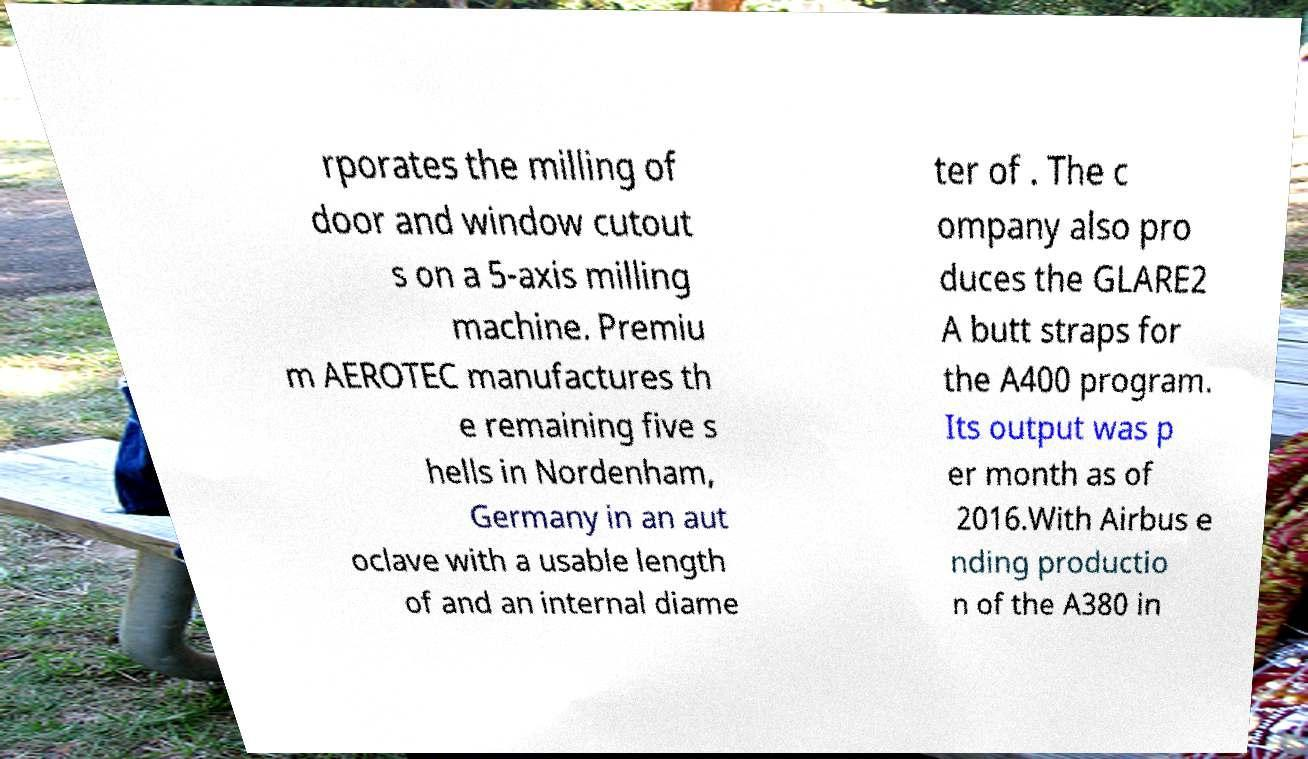Please read and relay the text visible in this image. What does it say? rporates the milling of door and window cutout s on a 5-axis milling machine. Premiu m AEROTEC manufactures th e remaining five s hells in Nordenham, Germany in an aut oclave with a usable length of and an internal diame ter of . The c ompany also pro duces the GLARE2 A butt straps for the A400 program. Its output was p er month as of 2016.With Airbus e nding productio n of the A380 in 